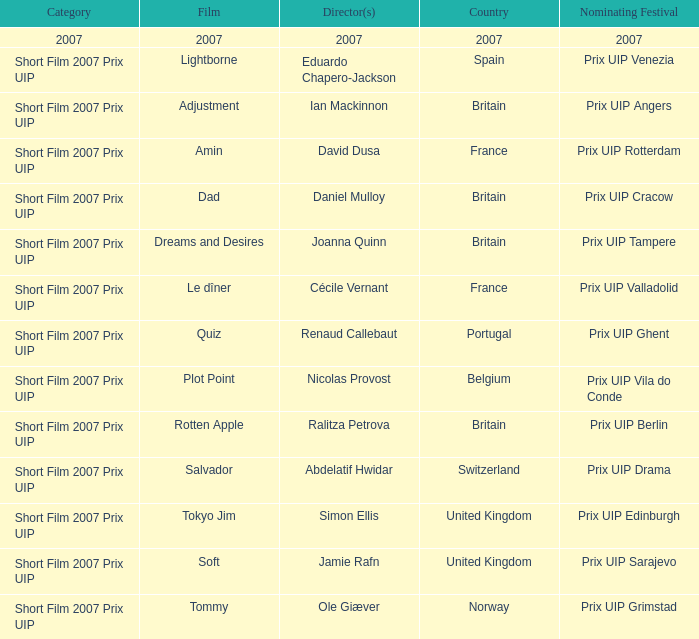Which film was recorded in spain? Lightborne. 